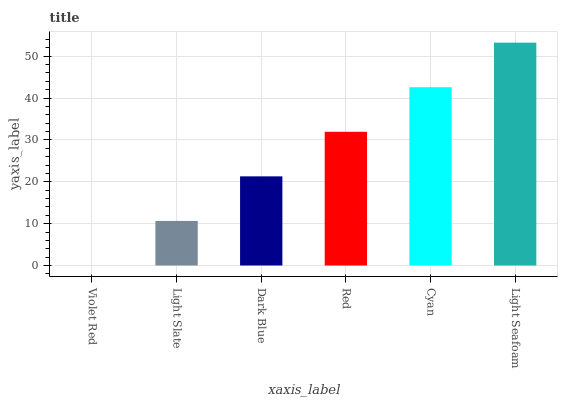Is Violet Red the minimum?
Answer yes or no. Yes. Is Light Seafoam the maximum?
Answer yes or no. Yes. Is Light Slate the minimum?
Answer yes or no. No. Is Light Slate the maximum?
Answer yes or no. No. Is Light Slate greater than Violet Red?
Answer yes or no. Yes. Is Violet Red less than Light Slate?
Answer yes or no. Yes. Is Violet Red greater than Light Slate?
Answer yes or no. No. Is Light Slate less than Violet Red?
Answer yes or no. No. Is Red the high median?
Answer yes or no. Yes. Is Dark Blue the low median?
Answer yes or no. Yes. Is Light Seafoam the high median?
Answer yes or no. No. Is Light Seafoam the low median?
Answer yes or no. No. 